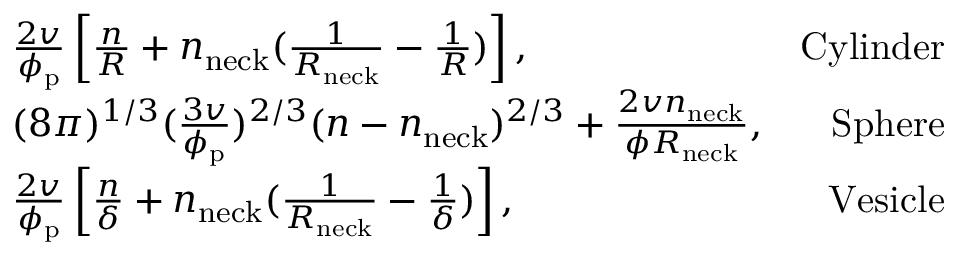<formula> <loc_0><loc_0><loc_500><loc_500>\begin{array} { r l r } & { \frac { 2 v } { \phi _ { p } } \left [ \frac { n } { R } + n _ { n e c k } ( \frac { 1 } { R _ { n e c k } } - \frac { 1 } { R } ) \right ] , } & { C y l i n d e r } \\ & { ( 8 \pi ) ^ { 1 / 3 } ( \frac { 3 v } { \phi _ { p } } ) ^ { 2 / 3 } ( n - n _ { n e c k } ) ^ { 2 / 3 } + \frac { 2 v n _ { n e c k } } { \phi R _ { n e c k } } , } & { S p h e r e } \\ & { \frac { 2 v } { \phi _ { p } } \left [ \frac { n } { \delta } + n _ { n e c k } ( \frac { 1 } { R _ { n e c k } } - \frac { 1 } { \delta } ) \right ] , } & { V e s i c l e } \end{array}</formula> 